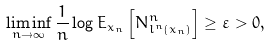<formula> <loc_0><loc_0><loc_500><loc_500>\liminf _ { n \rightarrow \infty } \frac { 1 } { n } \log E _ { x _ { n } } \left [ N _ { l ^ { n } ( x _ { n } ) } ^ { n } \right ] \geq \varepsilon > 0 ,</formula> 